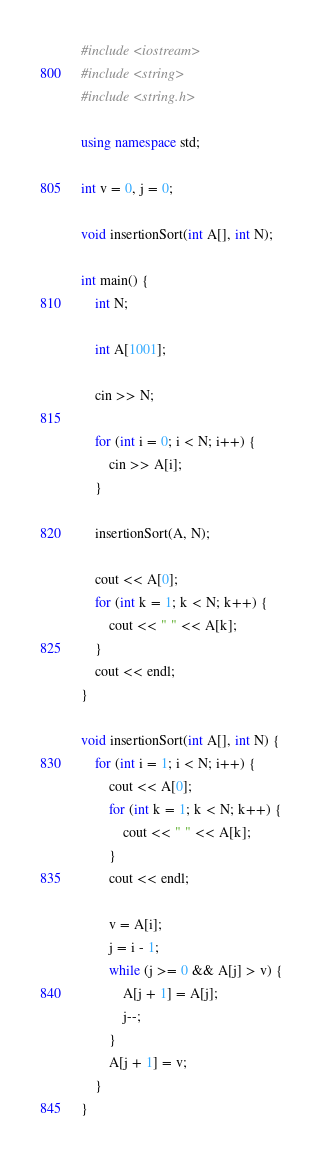Convert code to text. <code><loc_0><loc_0><loc_500><loc_500><_C++_>#include <iostream>
#include <string>
#include <string.h>

using namespace std;

int v = 0, j = 0;

void insertionSort(int A[], int N);

int main() {
	int N;

	int A[1001];

	cin >> N;

	for (int i = 0; i < N; i++) {
		cin >> A[i];	
	}
	
	insertionSort(A, N);

	cout << A[0];
	for (int k = 1; k < N; k++) {
		cout << " " << A[k];
	}
	cout << endl;
}
		
void insertionSort(int A[], int N) {
	for (int i = 1; i < N; i++) {
		cout << A[0];
		for (int k = 1; k < N; k++) {
			cout << " " << A[k];
		}
		cout << endl;

		v = A[i];
		j = i - 1;
		while (j >= 0 && A[j] > v) {
			A[j + 1] = A[j];
			j--;
		}
		A[j + 1] = v;
	}
}
</code> 